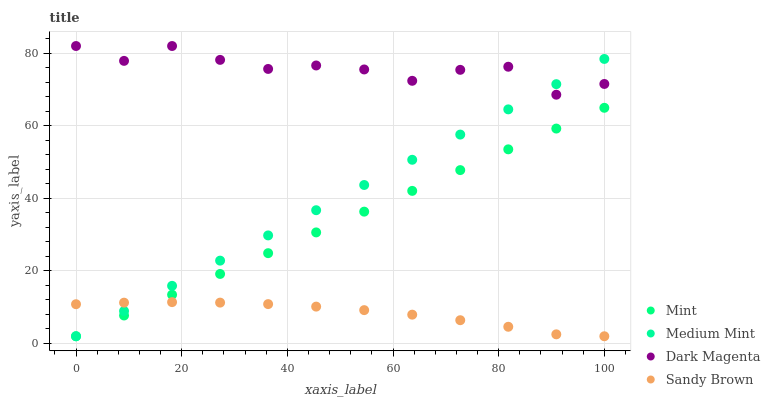Does Sandy Brown have the minimum area under the curve?
Answer yes or no. Yes. Does Dark Magenta have the maximum area under the curve?
Answer yes or no. Yes. Does Mint have the minimum area under the curve?
Answer yes or no. No. Does Mint have the maximum area under the curve?
Answer yes or no. No. Is Mint the smoothest?
Answer yes or no. Yes. Is Dark Magenta the roughest?
Answer yes or no. Yes. Is Sandy Brown the smoothest?
Answer yes or no. No. Is Sandy Brown the roughest?
Answer yes or no. No. Does Medium Mint have the lowest value?
Answer yes or no. Yes. Does Dark Magenta have the lowest value?
Answer yes or no. No. Does Dark Magenta have the highest value?
Answer yes or no. Yes. Does Mint have the highest value?
Answer yes or no. No. Is Mint less than Dark Magenta?
Answer yes or no. Yes. Is Dark Magenta greater than Mint?
Answer yes or no. Yes. Does Sandy Brown intersect Medium Mint?
Answer yes or no. Yes. Is Sandy Brown less than Medium Mint?
Answer yes or no. No. Is Sandy Brown greater than Medium Mint?
Answer yes or no. No. Does Mint intersect Dark Magenta?
Answer yes or no. No. 